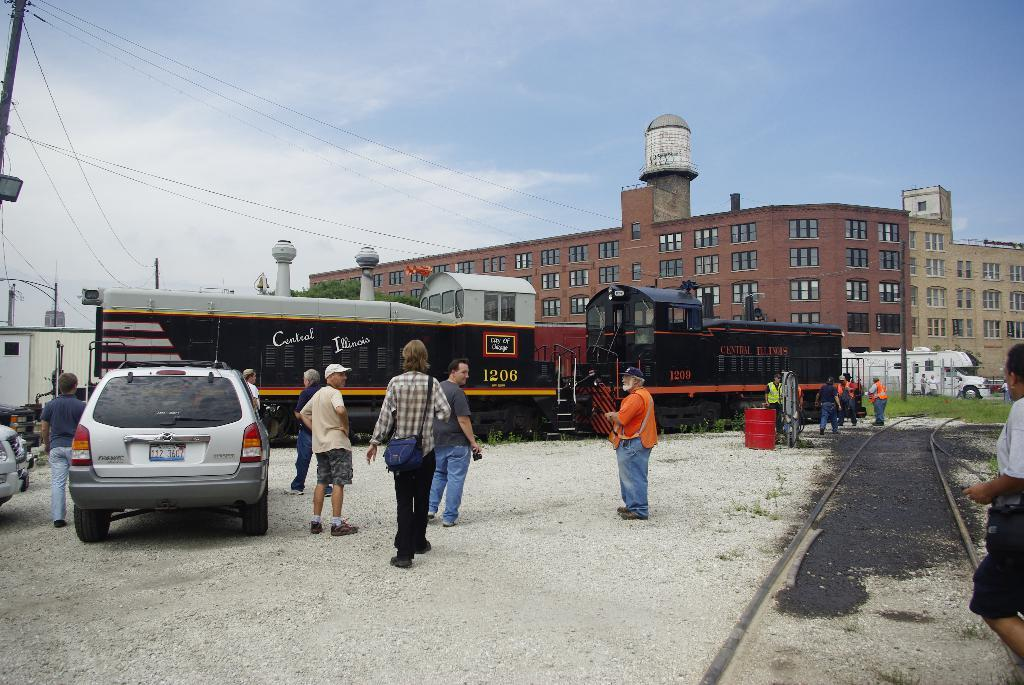What is the main subject of the image? The main subject of the image is a train. What other types of transportation can be seen in the image? There are vehicles in the image. What are the people in the image doing? There are people walking in the image. What type of structures are visible in the image? There are buildings in the image. What objects are present near the buildings? There are poles in the image, and wires are attached to the poles. What is visible at the top of the image? The sky is visible at the top of the image. What type of desk can be seen in the image? There is no desk present in the image. How does the throat of the person walking in the image look? The image does not show the person's throat, so it cannot be determined from the image. 